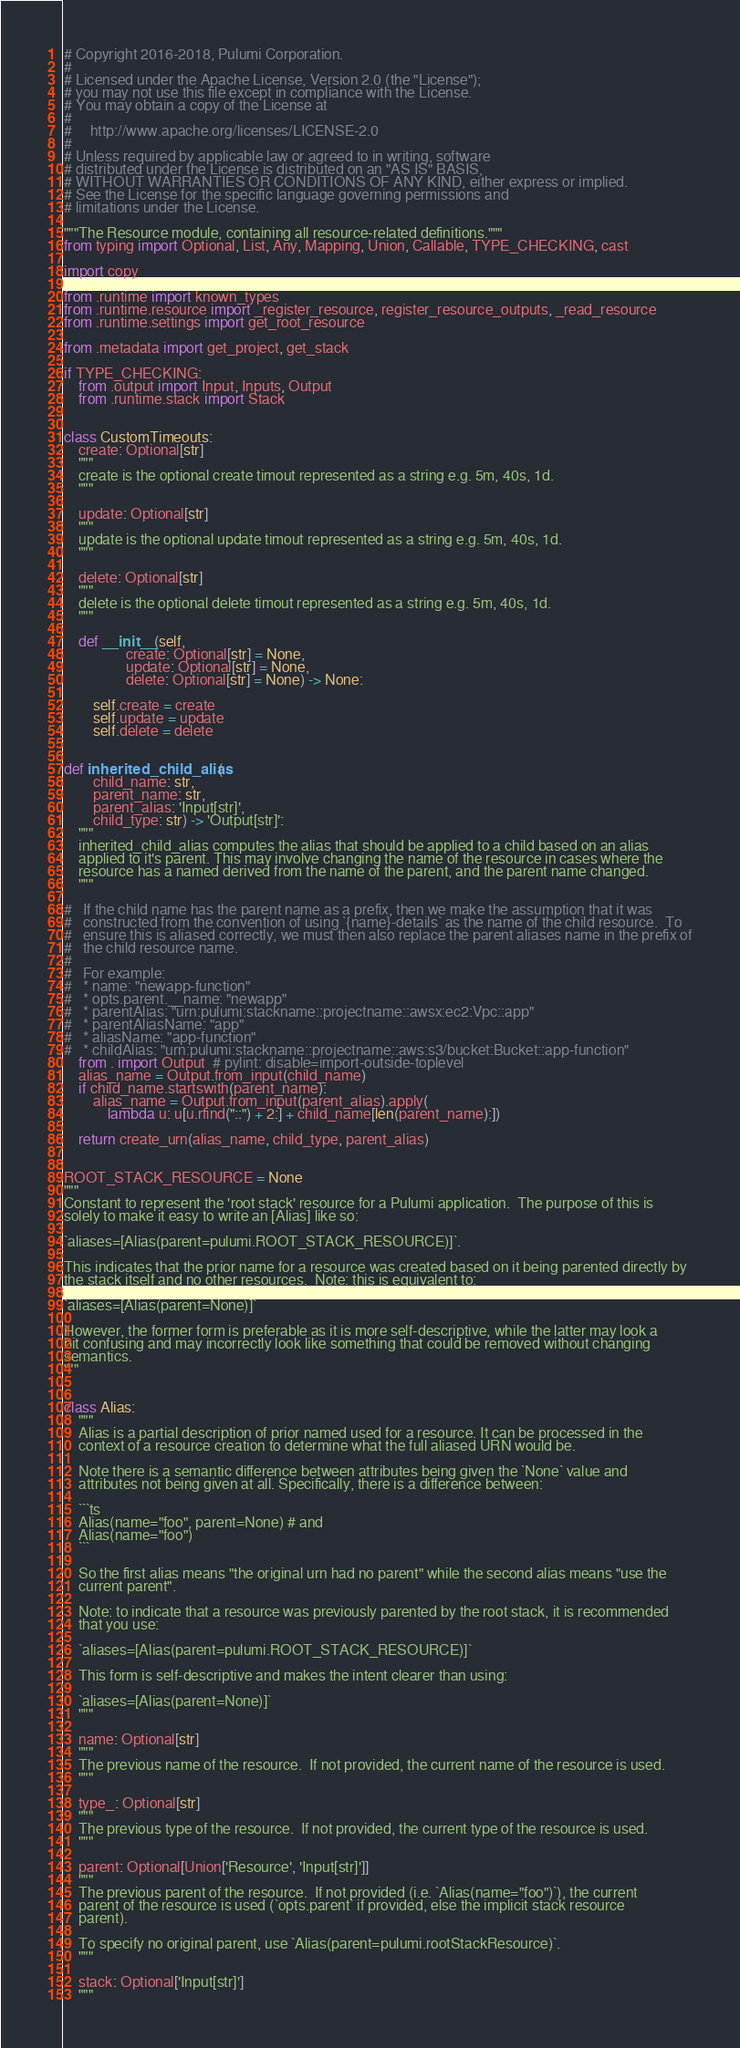Convert code to text. <code><loc_0><loc_0><loc_500><loc_500><_Python_># Copyright 2016-2018, Pulumi Corporation.
#
# Licensed under the Apache License, Version 2.0 (the "License");
# you may not use this file except in compliance with the License.
# You may obtain a copy of the License at
#
#     http://www.apache.org/licenses/LICENSE-2.0
#
# Unless required by applicable law or agreed to in writing, software
# distributed under the License is distributed on an "AS IS" BASIS,
# WITHOUT WARRANTIES OR CONDITIONS OF ANY KIND, either express or implied.
# See the License for the specific language governing permissions and
# limitations under the License.

"""The Resource module, containing all resource-related definitions."""
from typing import Optional, List, Any, Mapping, Union, Callable, TYPE_CHECKING, cast

import copy

from .runtime import known_types
from .runtime.resource import _register_resource, register_resource_outputs, _read_resource
from .runtime.settings import get_root_resource

from .metadata import get_project, get_stack

if TYPE_CHECKING:
    from .output import Input, Inputs, Output
    from .runtime.stack import Stack


class CustomTimeouts:
    create: Optional[str]
    """
    create is the optional create timout represented as a string e.g. 5m, 40s, 1d.
    """

    update: Optional[str]
    """
    update is the optional update timout represented as a string e.g. 5m, 40s, 1d.
    """

    delete: Optional[str]
    """
    delete is the optional delete timout represented as a string e.g. 5m, 40s, 1d.
    """

    def __init__(self,
                 create: Optional[str] = None,
                 update: Optional[str] = None,
                 delete: Optional[str] = None) -> None:

        self.create = create
        self.update = update
        self.delete = delete


def inherited_child_alias(
        child_name: str,
        parent_name: str,
        parent_alias: 'Input[str]',
        child_type: str) -> 'Output[str]':
    """
    inherited_child_alias computes the alias that should be applied to a child based on an alias
    applied to it's parent. This may involve changing the name of the resource in cases where the
    resource has a named derived from the name of the parent, and the parent name changed.
    """

#   If the child name has the parent name as a prefix, then we make the assumption that it was
#   constructed from the convention of using `{name}-details` as the name of the child resource.  To
#   ensure this is aliased correctly, we must then also replace the parent aliases name in the prefix of
#   the child resource name.
#
#   For example:
#   * name: "newapp-function"
#   * opts.parent.__name: "newapp"
#   * parentAlias: "urn:pulumi:stackname::projectname::awsx:ec2:Vpc::app"
#   * parentAliasName: "app"
#   * aliasName: "app-function"
#   * childAlias: "urn:pulumi:stackname::projectname::aws:s3/bucket:Bucket::app-function"
    from . import Output  # pylint: disable=import-outside-toplevel
    alias_name = Output.from_input(child_name)
    if child_name.startswith(parent_name):
        alias_name = Output.from_input(parent_alias).apply(
            lambda u: u[u.rfind("::") + 2:] + child_name[len(parent_name):])

    return create_urn(alias_name, child_type, parent_alias)


ROOT_STACK_RESOURCE = None
"""
Constant to represent the 'root stack' resource for a Pulumi application.  The purpose of this is
solely to make it easy to write an [Alias] like so:

`aliases=[Alias(parent=pulumi.ROOT_STACK_RESOURCE)]`.

This indicates that the prior name for a resource was created based on it being parented directly by
the stack itself and no other resources.  Note: this is equivalent to:

`aliases=[Alias(parent=None)]`

However, the former form is preferable as it is more self-descriptive, while the latter may look a
bit confusing and may incorrectly look like something that could be removed without changing
semantics.
"""


class Alias:
    """
    Alias is a partial description of prior named used for a resource. It can be processed in the
    context of a resource creation to determine what the full aliased URN would be.

    Note there is a semantic difference between attributes being given the `None` value and
    attributes not being given at all. Specifically, there is a difference between:

    ```ts
    Alias(name="foo", parent=None) # and
    Alias(name="foo")
    ```

    So the first alias means "the original urn had no parent" while the second alias means "use the
    current parent".

    Note: to indicate that a resource was previously parented by the root stack, it is recommended
    that you use:

    `aliases=[Alias(parent=pulumi.ROOT_STACK_RESOURCE)]`

    This form is self-descriptive and makes the intent clearer than using:

    `aliases=[Alias(parent=None)]`
    """

    name: Optional[str]
    """
    The previous name of the resource.  If not provided, the current name of the resource is used.
    """

    type_: Optional[str]
    """
    The previous type of the resource.  If not provided, the current type of the resource is used.
    """

    parent: Optional[Union['Resource', 'Input[str]']]
    """
    The previous parent of the resource.  If not provided (i.e. `Alias(name="foo")`), the current
    parent of the resource is used (`opts.parent` if provided, else the implicit stack resource
    parent).

    To specify no original parent, use `Alias(parent=pulumi.rootStackResource)`.
    """

    stack: Optional['Input[str]']
    """</code> 